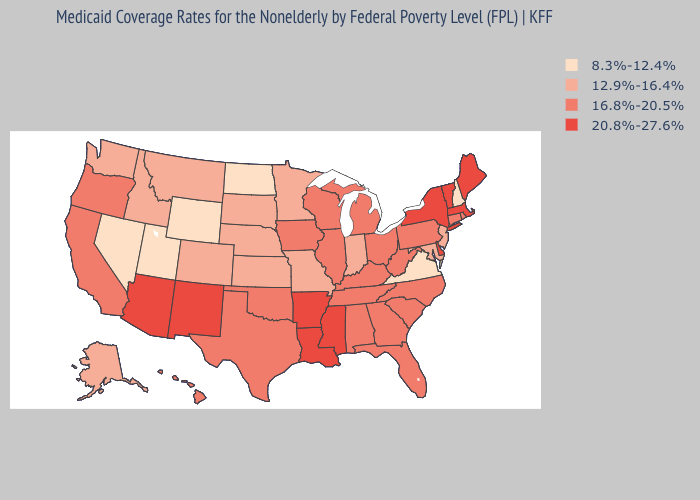What is the lowest value in states that border North Carolina?
Quick response, please. 8.3%-12.4%. Does Virginia have the lowest value in the USA?
Write a very short answer. Yes. Name the states that have a value in the range 12.9%-16.4%?
Concise answer only. Alaska, Colorado, Idaho, Indiana, Kansas, Maryland, Minnesota, Missouri, Montana, Nebraska, New Jersey, South Dakota, Washington. What is the value of Wisconsin?
Concise answer only. 16.8%-20.5%. Among the states that border Montana , does South Dakota have the highest value?
Quick response, please. Yes. What is the value of California?
Concise answer only. 16.8%-20.5%. What is the highest value in the Northeast ?
Answer briefly. 20.8%-27.6%. Which states have the lowest value in the MidWest?
Keep it brief. North Dakota. What is the highest value in the Northeast ?
Quick response, please. 20.8%-27.6%. Among the states that border Illinois , does Missouri have the lowest value?
Write a very short answer. Yes. Does New York have the highest value in the Northeast?
Write a very short answer. Yes. What is the lowest value in the USA?
Answer briefly. 8.3%-12.4%. Name the states that have a value in the range 16.8%-20.5%?
Concise answer only. Alabama, California, Connecticut, Florida, Georgia, Hawaii, Illinois, Iowa, Kentucky, Michigan, North Carolina, Ohio, Oklahoma, Oregon, Pennsylvania, Rhode Island, South Carolina, Tennessee, Texas, West Virginia, Wisconsin. What is the value of Maryland?
Keep it brief. 12.9%-16.4%. What is the value of Massachusetts?
Concise answer only. 20.8%-27.6%. 